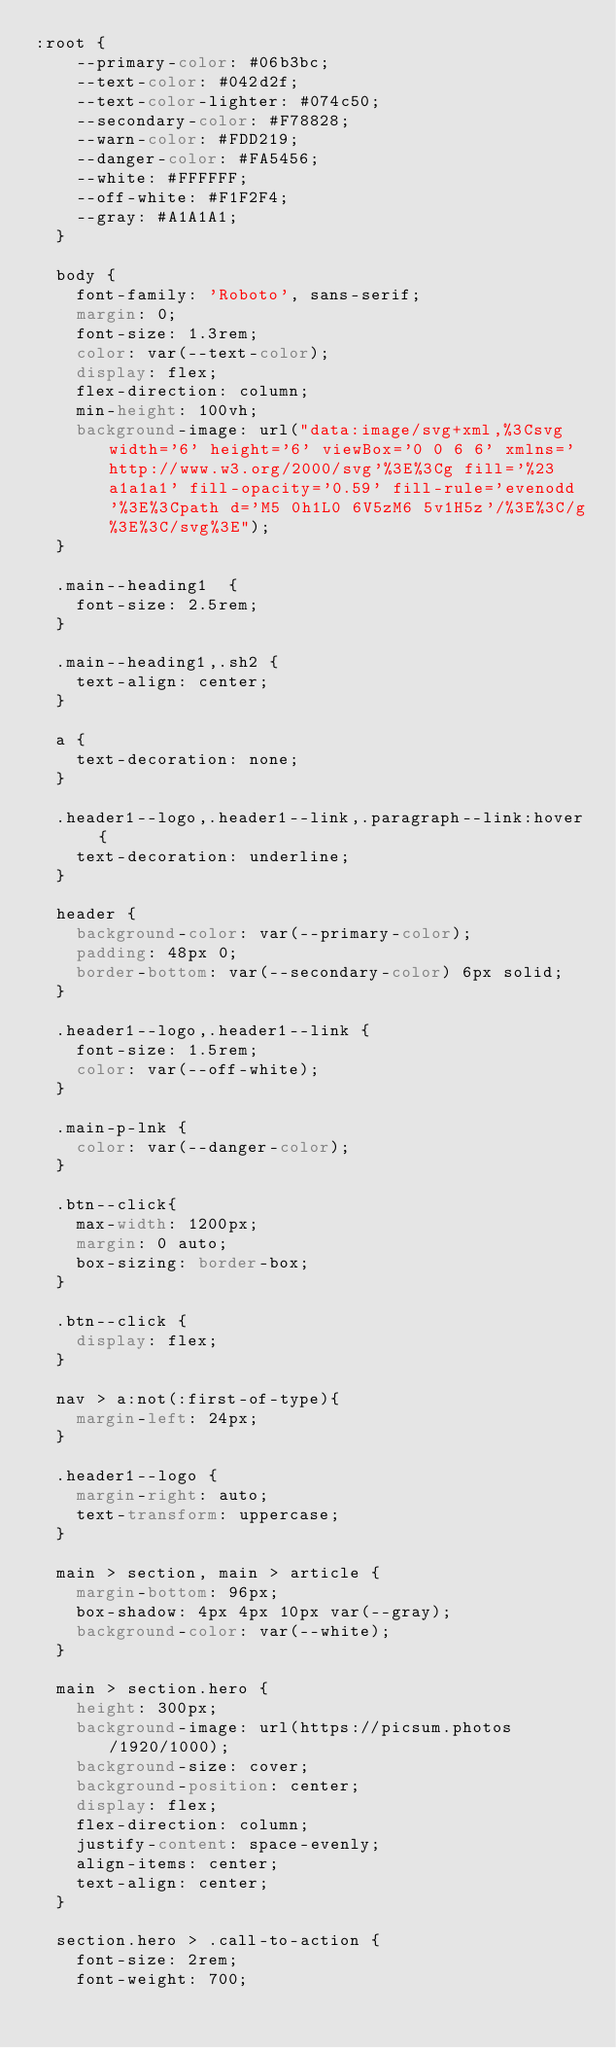Convert code to text. <code><loc_0><loc_0><loc_500><loc_500><_CSS_>:root {
    --primary-color: #06b3bc;
    --text-color: #042d2f;
    --text-color-lighter: #074c50;
    --secondary-color: #F78828;
    --warn-color: #FDD219;
    --danger-color: #FA5456;
    --white: #FFFFFF;
    --off-white: #F1F2F4;
    --gray: #A1A1A1;
  }
  
  body {
    font-family: 'Roboto', sans-serif;
    margin: 0;
    font-size: 1.3rem;
    color: var(--text-color);
    display: flex;
    flex-direction: column;
    min-height: 100vh;
    background-image: url("data:image/svg+xml,%3Csvg width='6' height='6' viewBox='0 0 6 6' xmlns='http://www.w3.org/2000/svg'%3E%3Cg fill='%23a1a1a1' fill-opacity='0.59' fill-rule='evenodd'%3E%3Cpath d='M5 0h1L0 6V5zM6 5v1H5z'/%3E%3C/g%3E%3C/svg%3E");
  }
  
  .main--heading1  {
    font-size: 2.5rem;
  }
  
  .main--heading1,.sh2 {
    text-align: center;
  }
  
  a {
    text-decoration: none;
  }
  
  .header1--logo,.header1--link,.paragraph--link:hover {
    text-decoration: underline;
  }
  
  header {
    background-color: var(--primary-color);
    padding: 48px 0;
    border-bottom: var(--secondary-color) 6px solid;
  }
  
  .header1--logo,.header1--link {
    font-size: 1.5rem;
    color: var(--off-white);
  }
  
  .main-p-lnk {
    color: var(--danger-color);
  }
  
  .btn--click{
    max-width: 1200px;
    margin: 0 auto;
    box-sizing: border-box;
  }
  
  .btn--click {
    display: flex;
  }
  
  nav > a:not(:first-of-type){
    margin-left: 24px;
  }
  
  .header1--logo {
    margin-right: auto;
    text-transform: uppercase;
  }
  
  main > section, main > article {
    margin-bottom: 96px;
    box-shadow: 4px 4px 10px var(--gray);
    background-color: var(--white);
  }
  
  main > section.hero {
    height: 300px;
    background-image: url(https://picsum.photos/1920/1000);
    background-size: cover;
    background-position: center;
    display: flex;
    flex-direction: column;
    justify-content: space-evenly;
    align-items: center;
    text-align: center;
  }
  
  section.hero > .call-to-action {
    font-size: 2rem;
    font-weight: 700;</code> 